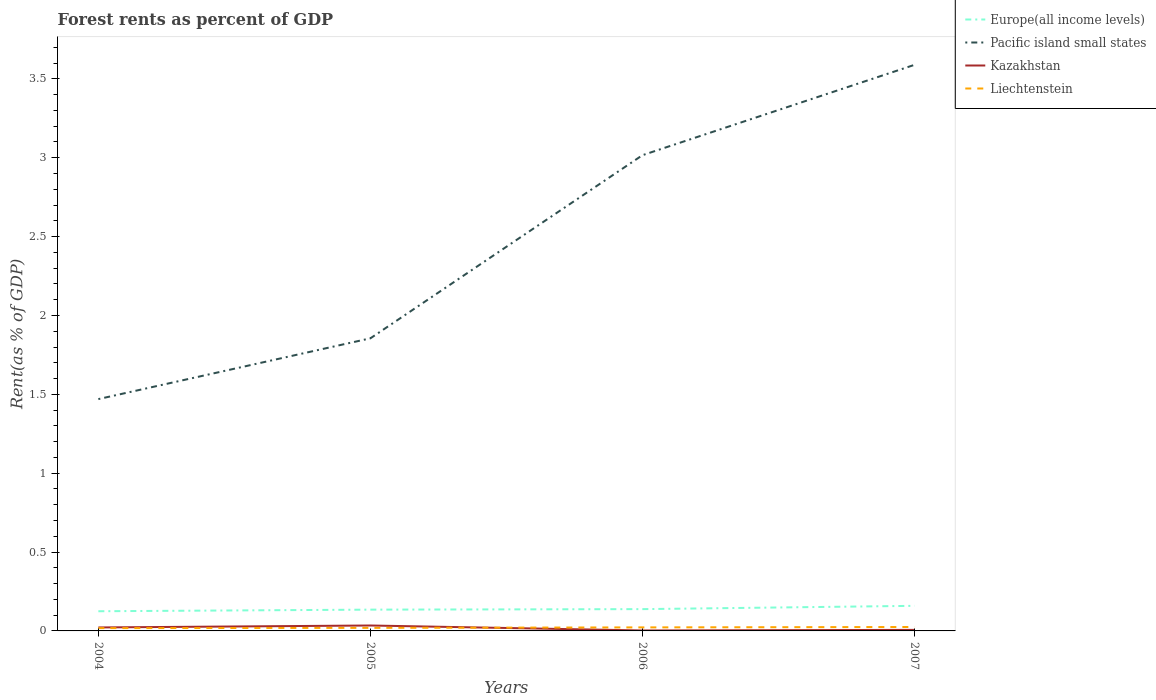Does the line corresponding to Kazakhstan intersect with the line corresponding to Liechtenstein?
Ensure brevity in your answer.  Yes. Is the number of lines equal to the number of legend labels?
Ensure brevity in your answer.  Yes. Across all years, what is the maximum forest rent in Pacific island small states?
Make the answer very short. 1.47. In which year was the forest rent in Europe(all income levels) maximum?
Keep it short and to the point. 2004. What is the total forest rent in Europe(all income levels) in the graph?
Make the answer very short. -0. What is the difference between the highest and the second highest forest rent in Europe(all income levels)?
Offer a very short reply. 0.03. What is the difference between the highest and the lowest forest rent in Pacific island small states?
Make the answer very short. 2. How many lines are there?
Make the answer very short. 4. What is the difference between two consecutive major ticks on the Y-axis?
Offer a terse response. 0.5. Are the values on the major ticks of Y-axis written in scientific E-notation?
Ensure brevity in your answer.  No. Does the graph contain any zero values?
Ensure brevity in your answer.  No. Where does the legend appear in the graph?
Your response must be concise. Top right. How are the legend labels stacked?
Ensure brevity in your answer.  Vertical. What is the title of the graph?
Keep it short and to the point. Forest rents as percent of GDP. What is the label or title of the Y-axis?
Your answer should be very brief. Rent(as % of GDP). What is the Rent(as % of GDP) of Europe(all income levels) in 2004?
Your response must be concise. 0.12. What is the Rent(as % of GDP) in Pacific island small states in 2004?
Provide a succinct answer. 1.47. What is the Rent(as % of GDP) in Kazakhstan in 2004?
Offer a very short reply. 0.02. What is the Rent(as % of GDP) in Liechtenstein in 2004?
Give a very brief answer. 0.02. What is the Rent(as % of GDP) of Europe(all income levels) in 2005?
Offer a very short reply. 0.13. What is the Rent(as % of GDP) in Pacific island small states in 2005?
Your answer should be very brief. 1.86. What is the Rent(as % of GDP) of Kazakhstan in 2005?
Ensure brevity in your answer.  0.03. What is the Rent(as % of GDP) in Liechtenstein in 2005?
Offer a very short reply. 0.02. What is the Rent(as % of GDP) in Europe(all income levels) in 2006?
Your response must be concise. 0.14. What is the Rent(as % of GDP) in Pacific island small states in 2006?
Make the answer very short. 3.02. What is the Rent(as % of GDP) in Kazakhstan in 2006?
Make the answer very short. 0. What is the Rent(as % of GDP) of Liechtenstein in 2006?
Provide a short and direct response. 0.02. What is the Rent(as % of GDP) in Europe(all income levels) in 2007?
Give a very brief answer. 0.16. What is the Rent(as % of GDP) of Pacific island small states in 2007?
Give a very brief answer. 3.59. What is the Rent(as % of GDP) in Kazakhstan in 2007?
Offer a very short reply. 0.01. What is the Rent(as % of GDP) in Liechtenstein in 2007?
Your answer should be very brief. 0.02. Across all years, what is the maximum Rent(as % of GDP) in Europe(all income levels)?
Your answer should be compact. 0.16. Across all years, what is the maximum Rent(as % of GDP) of Pacific island small states?
Your answer should be compact. 3.59. Across all years, what is the maximum Rent(as % of GDP) of Kazakhstan?
Offer a terse response. 0.03. Across all years, what is the maximum Rent(as % of GDP) of Liechtenstein?
Offer a terse response. 0.02. Across all years, what is the minimum Rent(as % of GDP) in Europe(all income levels)?
Your answer should be very brief. 0.12. Across all years, what is the minimum Rent(as % of GDP) in Pacific island small states?
Offer a very short reply. 1.47. Across all years, what is the minimum Rent(as % of GDP) in Kazakhstan?
Keep it short and to the point. 0. Across all years, what is the minimum Rent(as % of GDP) in Liechtenstein?
Provide a short and direct response. 0.02. What is the total Rent(as % of GDP) of Europe(all income levels) in the graph?
Your answer should be very brief. 0.56. What is the total Rent(as % of GDP) in Pacific island small states in the graph?
Your answer should be very brief. 9.93. What is the total Rent(as % of GDP) of Kazakhstan in the graph?
Give a very brief answer. 0.07. What is the total Rent(as % of GDP) in Liechtenstein in the graph?
Offer a very short reply. 0.08. What is the difference between the Rent(as % of GDP) of Europe(all income levels) in 2004 and that in 2005?
Ensure brevity in your answer.  -0.01. What is the difference between the Rent(as % of GDP) of Pacific island small states in 2004 and that in 2005?
Keep it short and to the point. -0.39. What is the difference between the Rent(as % of GDP) in Kazakhstan in 2004 and that in 2005?
Make the answer very short. -0.01. What is the difference between the Rent(as % of GDP) in Liechtenstein in 2004 and that in 2005?
Give a very brief answer. -0. What is the difference between the Rent(as % of GDP) in Europe(all income levels) in 2004 and that in 2006?
Your answer should be very brief. -0.01. What is the difference between the Rent(as % of GDP) of Pacific island small states in 2004 and that in 2006?
Keep it short and to the point. -1.55. What is the difference between the Rent(as % of GDP) in Kazakhstan in 2004 and that in 2006?
Offer a terse response. 0.02. What is the difference between the Rent(as % of GDP) in Liechtenstein in 2004 and that in 2006?
Your response must be concise. -0. What is the difference between the Rent(as % of GDP) in Europe(all income levels) in 2004 and that in 2007?
Keep it short and to the point. -0.03. What is the difference between the Rent(as % of GDP) in Pacific island small states in 2004 and that in 2007?
Your response must be concise. -2.12. What is the difference between the Rent(as % of GDP) in Kazakhstan in 2004 and that in 2007?
Give a very brief answer. 0.02. What is the difference between the Rent(as % of GDP) of Liechtenstein in 2004 and that in 2007?
Your response must be concise. -0.01. What is the difference between the Rent(as % of GDP) of Europe(all income levels) in 2005 and that in 2006?
Your response must be concise. -0. What is the difference between the Rent(as % of GDP) of Pacific island small states in 2005 and that in 2006?
Your answer should be very brief. -1.16. What is the difference between the Rent(as % of GDP) in Kazakhstan in 2005 and that in 2006?
Ensure brevity in your answer.  0.03. What is the difference between the Rent(as % of GDP) in Liechtenstein in 2005 and that in 2006?
Offer a very short reply. -0. What is the difference between the Rent(as % of GDP) in Europe(all income levels) in 2005 and that in 2007?
Make the answer very short. -0.02. What is the difference between the Rent(as % of GDP) in Pacific island small states in 2005 and that in 2007?
Provide a succinct answer. -1.73. What is the difference between the Rent(as % of GDP) of Kazakhstan in 2005 and that in 2007?
Provide a short and direct response. 0.03. What is the difference between the Rent(as % of GDP) in Liechtenstein in 2005 and that in 2007?
Give a very brief answer. -0.01. What is the difference between the Rent(as % of GDP) in Europe(all income levels) in 2006 and that in 2007?
Provide a succinct answer. -0.02. What is the difference between the Rent(as % of GDP) in Pacific island small states in 2006 and that in 2007?
Offer a very short reply. -0.57. What is the difference between the Rent(as % of GDP) of Kazakhstan in 2006 and that in 2007?
Offer a terse response. -0. What is the difference between the Rent(as % of GDP) of Liechtenstein in 2006 and that in 2007?
Give a very brief answer. -0. What is the difference between the Rent(as % of GDP) of Europe(all income levels) in 2004 and the Rent(as % of GDP) of Pacific island small states in 2005?
Keep it short and to the point. -1.73. What is the difference between the Rent(as % of GDP) of Europe(all income levels) in 2004 and the Rent(as % of GDP) of Kazakhstan in 2005?
Make the answer very short. 0.09. What is the difference between the Rent(as % of GDP) in Europe(all income levels) in 2004 and the Rent(as % of GDP) in Liechtenstein in 2005?
Your response must be concise. 0.11. What is the difference between the Rent(as % of GDP) in Pacific island small states in 2004 and the Rent(as % of GDP) in Kazakhstan in 2005?
Offer a very short reply. 1.44. What is the difference between the Rent(as % of GDP) in Pacific island small states in 2004 and the Rent(as % of GDP) in Liechtenstein in 2005?
Ensure brevity in your answer.  1.45. What is the difference between the Rent(as % of GDP) in Kazakhstan in 2004 and the Rent(as % of GDP) in Liechtenstein in 2005?
Offer a terse response. 0. What is the difference between the Rent(as % of GDP) in Europe(all income levels) in 2004 and the Rent(as % of GDP) in Pacific island small states in 2006?
Ensure brevity in your answer.  -2.89. What is the difference between the Rent(as % of GDP) in Europe(all income levels) in 2004 and the Rent(as % of GDP) in Kazakhstan in 2006?
Your answer should be compact. 0.12. What is the difference between the Rent(as % of GDP) in Europe(all income levels) in 2004 and the Rent(as % of GDP) in Liechtenstein in 2006?
Your response must be concise. 0.1. What is the difference between the Rent(as % of GDP) in Pacific island small states in 2004 and the Rent(as % of GDP) in Kazakhstan in 2006?
Provide a short and direct response. 1.47. What is the difference between the Rent(as % of GDP) in Pacific island small states in 2004 and the Rent(as % of GDP) in Liechtenstein in 2006?
Make the answer very short. 1.45. What is the difference between the Rent(as % of GDP) in Kazakhstan in 2004 and the Rent(as % of GDP) in Liechtenstein in 2006?
Your answer should be compact. -0. What is the difference between the Rent(as % of GDP) of Europe(all income levels) in 2004 and the Rent(as % of GDP) of Pacific island small states in 2007?
Offer a very short reply. -3.46. What is the difference between the Rent(as % of GDP) of Europe(all income levels) in 2004 and the Rent(as % of GDP) of Kazakhstan in 2007?
Your answer should be very brief. 0.12. What is the difference between the Rent(as % of GDP) in Europe(all income levels) in 2004 and the Rent(as % of GDP) in Liechtenstein in 2007?
Offer a very short reply. 0.1. What is the difference between the Rent(as % of GDP) in Pacific island small states in 2004 and the Rent(as % of GDP) in Kazakhstan in 2007?
Provide a succinct answer. 1.46. What is the difference between the Rent(as % of GDP) of Pacific island small states in 2004 and the Rent(as % of GDP) of Liechtenstein in 2007?
Ensure brevity in your answer.  1.44. What is the difference between the Rent(as % of GDP) of Kazakhstan in 2004 and the Rent(as % of GDP) of Liechtenstein in 2007?
Make the answer very short. -0. What is the difference between the Rent(as % of GDP) of Europe(all income levels) in 2005 and the Rent(as % of GDP) of Pacific island small states in 2006?
Make the answer very short. -2.88. What is the difference between the Rent(as % of GDP) of Europe(all income levels) in 2005 and the Rent(as % of GDP) of Kazakhstan in 2006?
Give a very brief answer. 0.13. What is the difference between the Rent(as % of GDP) of Europe(all income levels) in 2005 and the Rent(as % of GDP) of Liechtenstein in 2006?
Provide a short and direct response. 0.11. What is the difference between the Rent(as % of GDP) of Pacific island small states in 2005 and the Rent(as % of GDP) of Kazakhstan in 2006?
Offer a very short reply. 1.85. What is the difference between the Rent(as % of GDP) in Pacific island small states in 2005 and the Rent(as % of GDP) in Liechtenstein in 2006?
Provide a short and direct response. 1.83. What is the difference between the Rent(as % of GDP) in Kazakhstan in 2005 and the Rent(as % of GDP) in Liechtenstein in 2006?
Offer a very short reply. 0.01. What is the difference between the Rent(as % of GDP) of Europe(all income levels) in 2005 and the Rent(as % of GDP) of Pacific island small states in 2007?
Make the answer very short. -3.45. What is the difference between the Rent(as % of GDP) in Europe(all income levels) in 2005 and the Rent(as % of GDP) in Kazakhstan in 2007?
Your response must be concise. 0.13. What is the difference between the Rent(as % of GDP) of Europe(all income levels) in 2005 and the Rent(as % of GDP) of Liechtenstein in 2007?
Ensure brevity in your answer.  0.11. What is the difference between the Rent(as % of GDP) of Pacific island small states in 2005 and the Rent(as % of GDP) of Kazakhstan in 2007?
Provide a succinct answer. 1.85. What is the difference between the Rent(as % of GDP) of Pacific island small states in 2005 and the Rent(as % of GDP) of Liechtenstein in 2007?
Offer a terse response. 1.83. What is the difference between the Rent(as % of GDP) of Kazakhstan in 2005 and the Rent(as % of GDP) of Liechtenstein in 2007?
Offer a terse response. 0.01. What is the difference between the Rent(as % of GDP) of Europe(all income levels) in 2006 and the Rent(as % of GDP) of Pacific island small states in 2007?
Your response must be concise. -3.45. What is the difference between the Rent(as % of GDP) of Europe(all income levels) in 2006 and the Rent(as % of GDP) of Kazakhstan in 2007?
Your response must be concise. 0.13. What is the difference between the Rent(as % of GDP) of Europe(all income levels) in 2006 and the Rent(as % of GDP) of Liechtenstein in 2007?
Your answer should be very brief. 0.11. What is the difference between the Rent(as % of GDP) of Pacific island small states in 2006 and the Rent(as % of GDP) of Kazakhstan in 2007?
Make the answer very short. 3.01. What is the difference between the Rent(as % of GDP) of Pacific island small states in 2006 and the Rent(as % of GDP) of Liechtenstein in 2007?
Ensure brevity in your answer.  2.99. What is the difference between the Rent(as % of GDP) of Kazakhstan in 2006 and the Rent(as % of GDP) of Liechtenstein in 2007?
Your response must be concise. -0.02. What is the average Rent(as % of GDP) of Europe(all income levels) per year?
Make the answer very short. 0.14. What is the average Rent(as % of GDP) of Pacific island small states per year?
Keep it short and to the point. 2.48. What is the average Rent(as % of GDP) of Kazakhstan per year?
Give a very brief answer. 0.02. What is the average Rent(as % of GDP) of Liechtenstein per year?
Ensure brevity in your answer.  0.02. In the year 2004, what is the difference between the Rent(as % of GDP) in Europe(all income levels) and Rent(as % of GDP) in Pacific island small states?
Ensure brevity in your answer.  -1.34. In the year 2004, what is the difference between the Rent(as % of GDP) in Europe(all income levels) and Rent(as % of GDP) in Kazakhstan?
Ensure brevity in your answer.  0.1. In the year 2004, what is the difference between the Rent(as % of GDP) of Europe(all income levels) and Rent(as % of GDP) of Liechtenstein?
Give a very brief answer. 0.11. In the year 2004, what is the difference between the Rent(as % of GDP) of Pacific island small states and Rent(as % of GDP) of Kazakhstan?
Offer a very short reply. 1.45. In the year 2004, what is the difference between the Rent(as % of GDP) in Pacific island small states and Rent(as % of GDP) in Liechtenstein?
Provide a succinct answer. 1.45. In the year 2004, what is the difference between the Rent(as % of GDP) of Kazakhstan and Rent(as % of GDP) of Liechtenstein?
Your response must be concise. 0. In the year 2005, what is the difference between the Rent(as % of GDP) in Europe(all income levels) and Rent(as % of GDP) in Pacific island small states?
Your answer should be compact. -1.72. In the year 2005, what is the difference between the Rent(as % of GDP) in Europe(all income levels) and Rent(as % of GDP) in Kazakhstan?
Give a very brief answer. 0.1. In the year 2005, what is the difference between the Rent(as % of GDP) of Europe(all income levels) and Rent(as % of GDP) of Liechtenstein?
Your response must be concise. 0.12. In the year 2005, what is the difference between the Rent(as % of GDP) in Pacific island small states and Rent(as % of GDP) in Kazakhstan?
Make the answer very short. 1.82. In the year 2005, what is the difference between the Rent(as % of GDP) in Pacific island small states and Rent(as % of GDP) in Liechtenstein?
Give a very brief answer. 1.84. In the year 2005, what is the difference between the Rent(as % of GDP) in Kazakhstan and Rent(as % of GDP) in Liechtenstein?
Provide a short and direct response. 0.01. In the year 2006, what is the difference between the Rent(as % of GDP) of Europe(all income levels) and Rent(as % of GDP) of Pacific island small states?
Offer a terse response. -2.88. In the year 2006, what is the difference between the Rent(as % of GDP) of Europe(all income levels) and Rent(as % of GDP) of Kazakhstan?
Offer a very short reply. 0.14. In the year 2006, what is the difference between the Rent(as % of GDP) of Europe(all income levels) and Rent(as % of GDP) of Liechtenstein?
Make the answer very short. 0.12. In the year 2006, what is the difference between the Rent(as % of GDP) in Pacific island small states and Rent(as % of GDP) in Kazakhstan?
Ensure brevity in your answer.  3.01. In the year 2006, what is the difference between the Rent(as % of GDP) in Pacific island small states and Rent(as % of GDP) in Liechtenstein?
Give a very brief answer. 2.99. In the year 2006, what is the difference between the Rent(as % of GDP) of Kazakhstan and Rent(as % of GDP) of Liechtenstein?
Make the answer very short. -0.02. In the year 2007, what is the difference between the Rent(as % of GDP) of Europe(all income levels) and Rent(as % of GDP) of Pacific island small states?
Provide a succinct answer. -3.43. In the year 2007, what is the difference between the Rent(as % of GDP) of Europe(all income levels) and Rent(as % of GDP) of Kazakhstan?
Your answer should be very brief. 0.15. In the year 2007, what is the difference between the Rent(as % of GDP) in Europe(all income levels) and Rent(as % of GDP) in Liechtenstein?
Provide a succinct answer. 0.13. In the year 2007, what is the difference between the Rent(as % of GDP) of Pacific island small states and Rent(as % of GDP) of Kazakhstan?
Offer a very short reply. 3.58. In the year 2007, what is the difference between the Rent(as % of GDP) of Pacific island small states and Rent(as % of GDP) of Liechtenstein?
Give a very brief answer. 3.56. In the year 2007, what is the difference between the Rent(as % of GDP) of Kazakhstan and Rent(as % of GDP) of Liechtenstein?
Your response must be concise. -0.02. What is the ratio of the Rent(as % of GDP) of Europe(all income levels) in 2004 to that in 2005?
Provide a short and direct response. 0.92. What is the ratio of the Rent(as % of GDP) of Pacific island small states in 2004 to that in 2005?
Provide a short and direct response. 0.79. What is the ratio of the Rent(as % of GDP) in Kazakhstan in 2004 to that in 2005?
Ensure brevity in your answer.  0.64. What is the ratio of the Rent(as % of GDP) of Liechtenstein in 2004 to that in 2005?
Ensure brevity in your answer.  0.92. What is the ratio of the Rent(as % of GDP) of Europe(all income levels) in 2004 to that in 2006?
Make the answer very short. 0.9. What is the ratio of the Rent(as % of GDP) of Pacific island small states in 2004 to that in 2006?
Keep it short and to the point. 0.49. What is the ratio of the Rent(as % of GDP) in Kazakhstan in 2004 to that in 2006?
Offer a terse response. 7.66. What is the ratio of the Rent(as % of GDP) of Liechtenstein in 2004 to that in 2006?
Your answer should be compact. 0.79. What is the ratio of the Rent(as % of GDP) of Europe(all income levels) in 2004 to that in 2007?
Ensure brevity in your answer.  0.78. What is the ratio of the Rent(as % of GDP) in Pacific island small states in 2004 to that in 2007?
Your answer should be very brief. 0.41. What is the ratio of the Rent(as % of GDP) of Kazakhstan in 2004 to that in 2007?
Offer a very short reply. 3.35. What is the ratio of the Rent(as % of GDP) in Liechtenstein in 2004 to that in 2007?
Make the answer very short. 0.71. What is the ratio of the Rent(as % of GDP) in Europe(all income levels) in 2005 to that in 2006?
Give a very brief answer. 0.98. What is the ratio of the Rent(as % of GDP) of Pacific island small states in 2005 to that in 2006?
Make the answer very short. 0.62. What is the ratio of the Rent(as % of GDP) in Kazakhstan in 2005 to that in 2006?
Make the answer very short. 11.99. What is the ratio of the Rent(as % of GDP) of Liechtenstein in 2005 to that in 2006?
Make the answer very short. 0.86. What is the ratio of the Rent(as % of GDP) in Europe(all income levels) in 2005 to that in 2007?
Provide a short and direct response. 0.85. What is the ratio of the Rent(as % of GDP) in Pacific island small states in 2005 to that in 2007?
Offer a very short reply. 0.52. What is the ratio of the Rent(as % of GDP) of Kazakhstan in 2005 to that in 2007?
Offer a very short reply. 5.25. What is the ratio of the Rent(as % of GDP) of Liechtenstein in 2005 to that in 2007?
Your response must be concise. 0.78. What is the ratio of the Rent(as % of GDP) in Europe(all income levels) in 2006 to that in 2007?
Provide a succinct answer. 0.87. What is the ratio of the Rent(as % of GDP) of Pacific island small states in 2006 to that in 2007?
Offer a terse response. 0.84. What is the ratio of the Rent(as % of GDP) in Kazakhstan in 2006 to that in 2007?
Give a very brief answer. 0.44. What is the ratio of the Rent(as % of GDP) of Liechtenstein in 2006 to that in 2007?
Give a very brief answer. 0.9. What is the difference between the highest and the second highest Rent(as % of GDP) in Europe(all income levels)?
Offer a terse response. 0.02. What is the difference between the highest and the second highest Rent(as % of GDP) of Pacific island small states?
Provide a short and direct response. 0.57. What is the difference between the highest and the second highest Rent(as % of GDP) in Kazakhstan?
Make the answer very short. 0.01. What is the difference between the highest and the second highest Rent(as % of GDP) of Liechtenstein?
Make the answer very short. 0. What is the difference between the highest and the lowest Rent(as % of GDP) of Europe(all income levels)?
Ensure brevity in your answer.  0.03. What is the difference between the highest and the lowest Rent(as % of GDP) in Pacific island small states?
Give a very brief answer. 2.12. What is the difference between the highest and the lowest Rent(as % of GDP) of Kazakhstan?
Ensure brevity in your answer.  0.03. What is the difference between the highest and the lowest Rent(as % of GDP) of Liechtenstein?
Offer a very short reply. 0.01. 